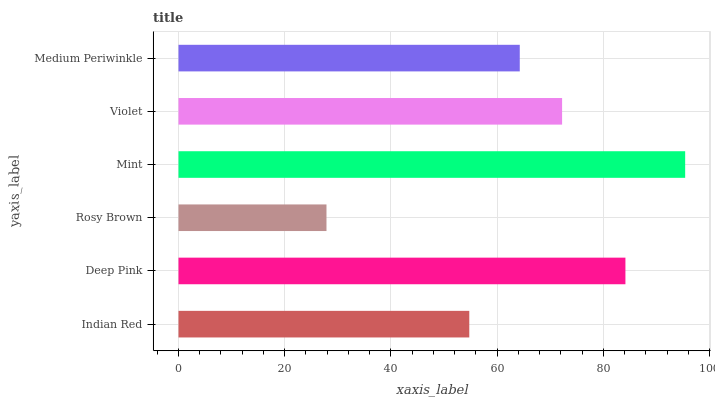Is Rosy Brown the minimum?
Answer yes or no. Yes. Is Mint the maximum?
Answer yes or no. Yes. Is Deep Pink the minimum?
Answer yes or no. No. Is Deep Pink the maximum?
Answer yes or no. No. Is Deep Pink greater than Indian Red?
Answer yes or no. Yes. Is Indian Red less than Deep Pink?
Answer yes or no. Yes. Is Indian Red greater than Deep Pink?
Answer yes or no. No. Is Deep Pink less than Indian Red?
Answer yes or no. No. Is Violet the high median?
Answer yes or no. Yes. Is Medium Periwinkle the low median?
Answer yes or no. Yes. Is Mint the high median?
Answer yes or no. No. Is Violet the low median?
Answer yes or no. No. 